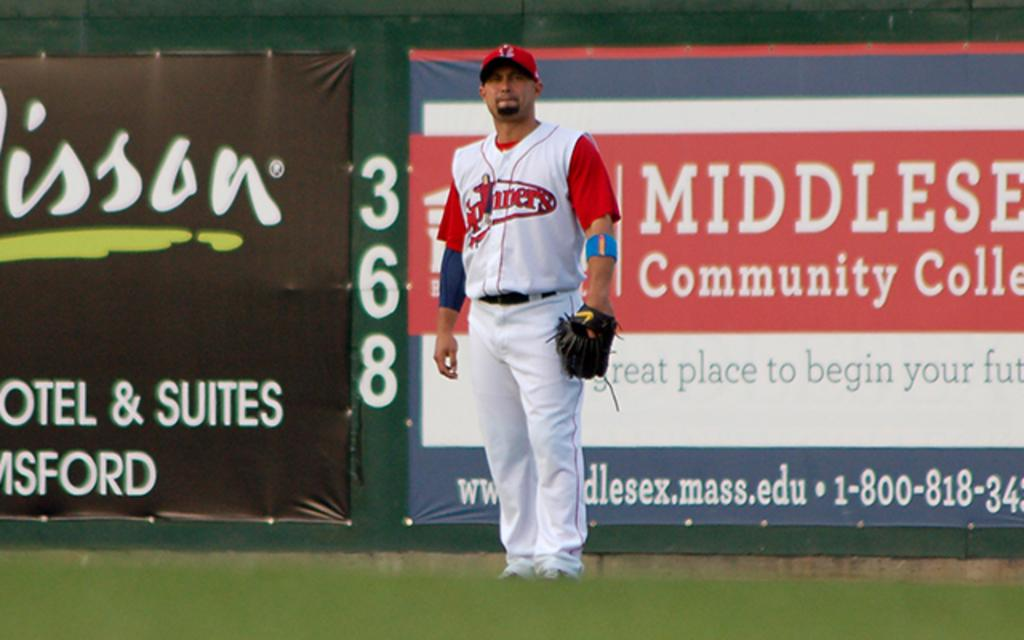<image>
Describe the image concisely. a person standing in a field with a community college advertisement behind them 